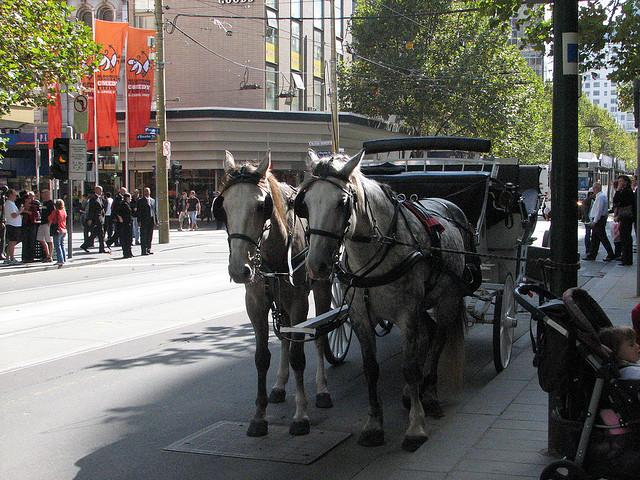What turn is forbidden? left 